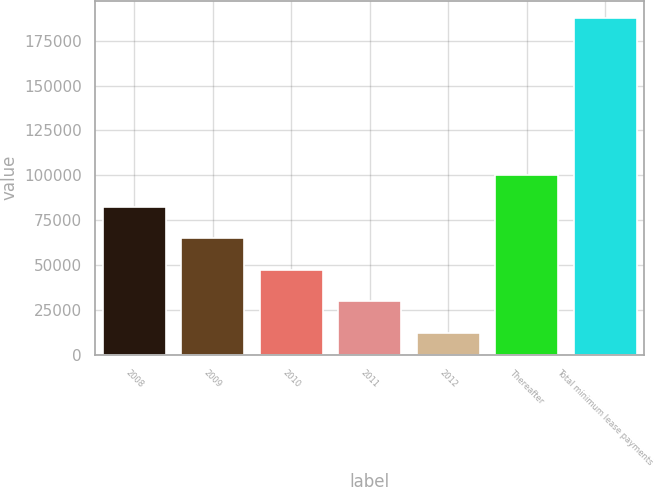<chart> <loc_0><loc_0><loc_500><loc_500><bar_chart><fcel>2008<fcel>2009<fcel>2010<fcel>2011<fcel>2012<fcel>Thereafter<fcel>Total minimum lease payments<nl><fcel>82470<fcel>64890<fcel>47310<fcel>29730<fcel>12150<fcel>100050<fcel>187950<nl></chart> 